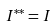<formula> <loc_0><loc_0><loc_500><loc_500>I ^ { * * } = I</formula> 